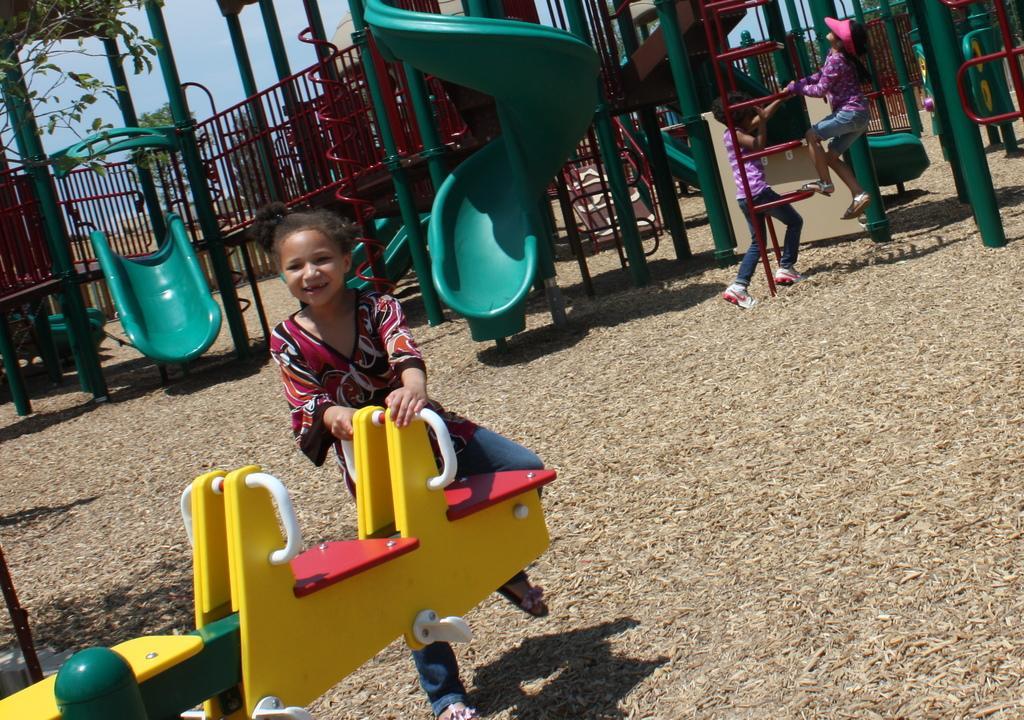Describe this image in one or two sentences. There is a girl holding a see saw. In the back other children are playing on other playing things. There are slides, ladders, railings and many other playing things in the background. On the left side we can see a part of a tree. In the background there is sky. 